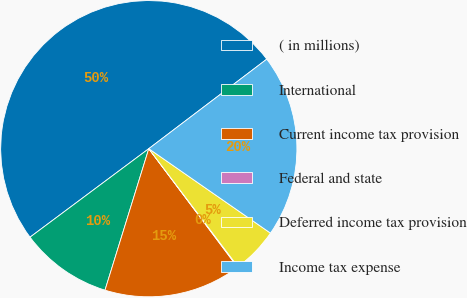<chart> <loc_0><loc_0><loc_500><loc_500><pie_chart><fcel>( in millions)<fcel>International<fcel>Current income tax provision<fcel>Federal and state<fcel>Deferred income tax provision<fcel>Income tax expense<nl><fcel>49.87%<fcel>10.03%<fcel>15.01%<fcel>0.07%<fcel>5.05%<fcel>19.99%<nl></chart> 